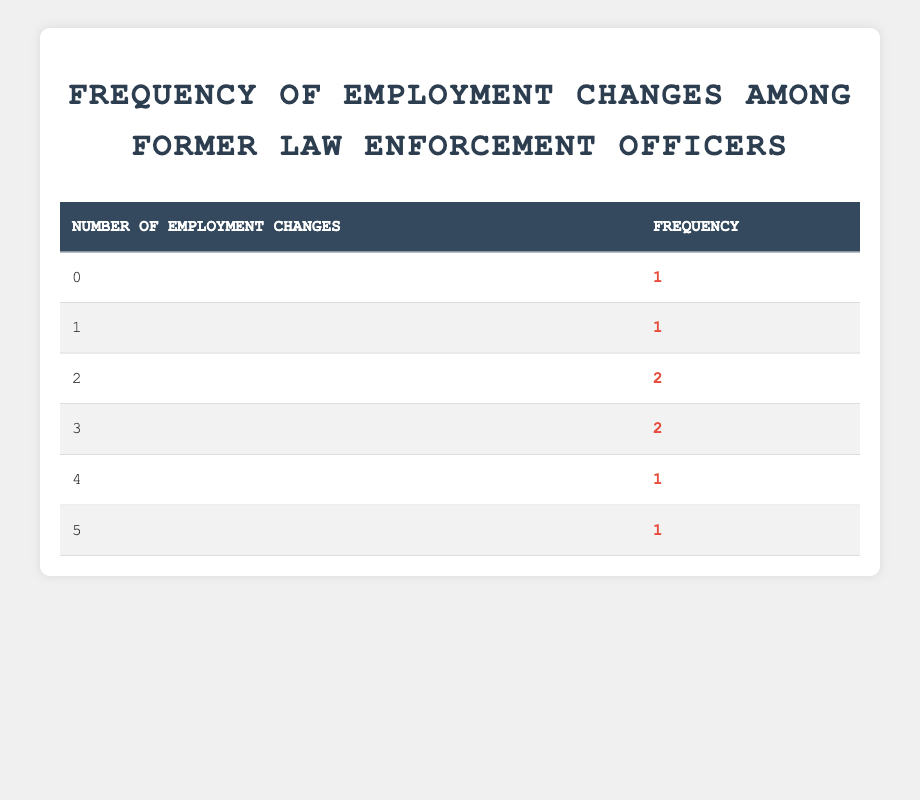What is the frequency of former law enforcement officers who have had no employment changes? In the table, under the "Number of Employment Changes" column, the value "0" appears once in the "Frequency" column. This indicates that there is one former officer who has had no employment changes.
Answer: 1 How many former law enforcement officers have experienced exactly two employment changes? By checking the number of times "2" appears in the "Number of Employment Changes" column, it shows that it appears twice, meaning two former officers have had exactly two employment changes.
Answer: 2 What is the total number of former law enforcement officers represented in the table? To find the total number of former officers, we add up the frequencies from all rows: 1 + 1 + 2 + 2 + 1 + 1 = 8. There are 8 former officers represented in total.
Answer: 8 What is the average number of employment changes among the officers listed? To calculate the average, we first add up all the changes: (0*1) + (1*1) + (2*2) + (3*2) + (4*1) + (5*1) = 0 + 1 + 4 + 6 + 4 + 5 = 20. Next, we divide this sum by the total number of officers (8): 20 / 8 = 2.5. The average number of employment changes is 2.5.
Answer: 2.5 Is it true that more officers have experienced three employment changes than one? According to the table, the frequency of officers with three employment changes is 2 and with one employment change is 1. Since 2 is greater than 1, it is true that more officers have experienced three employment changes than one.
Answer: Yes What is the highest number of employment changes experienced by former officers and how many experienced that? The highest number recorded in the "Number of Employment Changes" column is 5 (from Karen Davis). Referring to the "Frequency" column, that value appears once, indicating that only one officer experienced five employment changes.
Answer: 1 